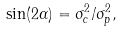<formula> <loc_0><loc_0><loc_500><loc_500>\sin ( 2 \alpha ) = \sigma _ { c } ^ { 2 } / \sigma _ { p } ^ { 2 } ,</formula> 